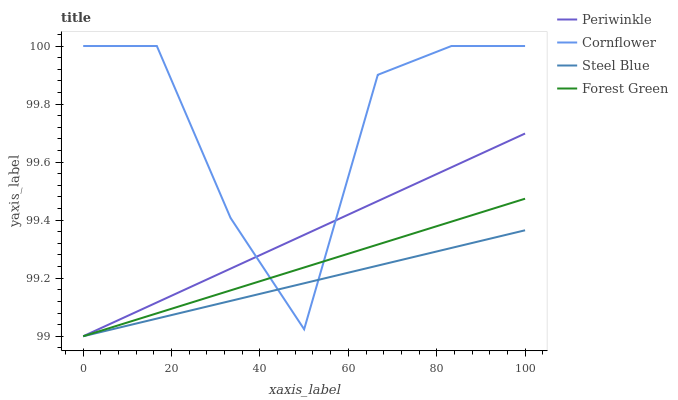Does Steel Blue have the minimum area under the curve?
Answer yes or no. Yes. Does Cornflower have the maximum area under the curve?
Answer yes or no. Yes. Does Forest Green have the minimum area under the curve?
Answer yes or no. No. Does Forest Green have the maximum area under the curve?
Answer yes or no. No. Is Periwinkle the smoothest?
Answer yes or no. Yes. Is Cornflower the roughest?
Answer yes or no. Yes. Is Forest Green the smoothest?
Answer yes or no. No. Is Forest Green the roughest?
Answer yes or no. No. Does Forest Green have the lowest value?
Answer yes or no. Yes. Does Cornflower have the highest value?
Answer yes or no. Yes. Does Forest Green have the highest value?
Answer yes or no. No. Does Steel Blue intersect Forest Green?
Answer yes or no. Yes. Is Steel Blue less than Forest Green?
Answer yes or no. No. Is Steel Blue greater than Forest Green?
Answer yes or no. No. 